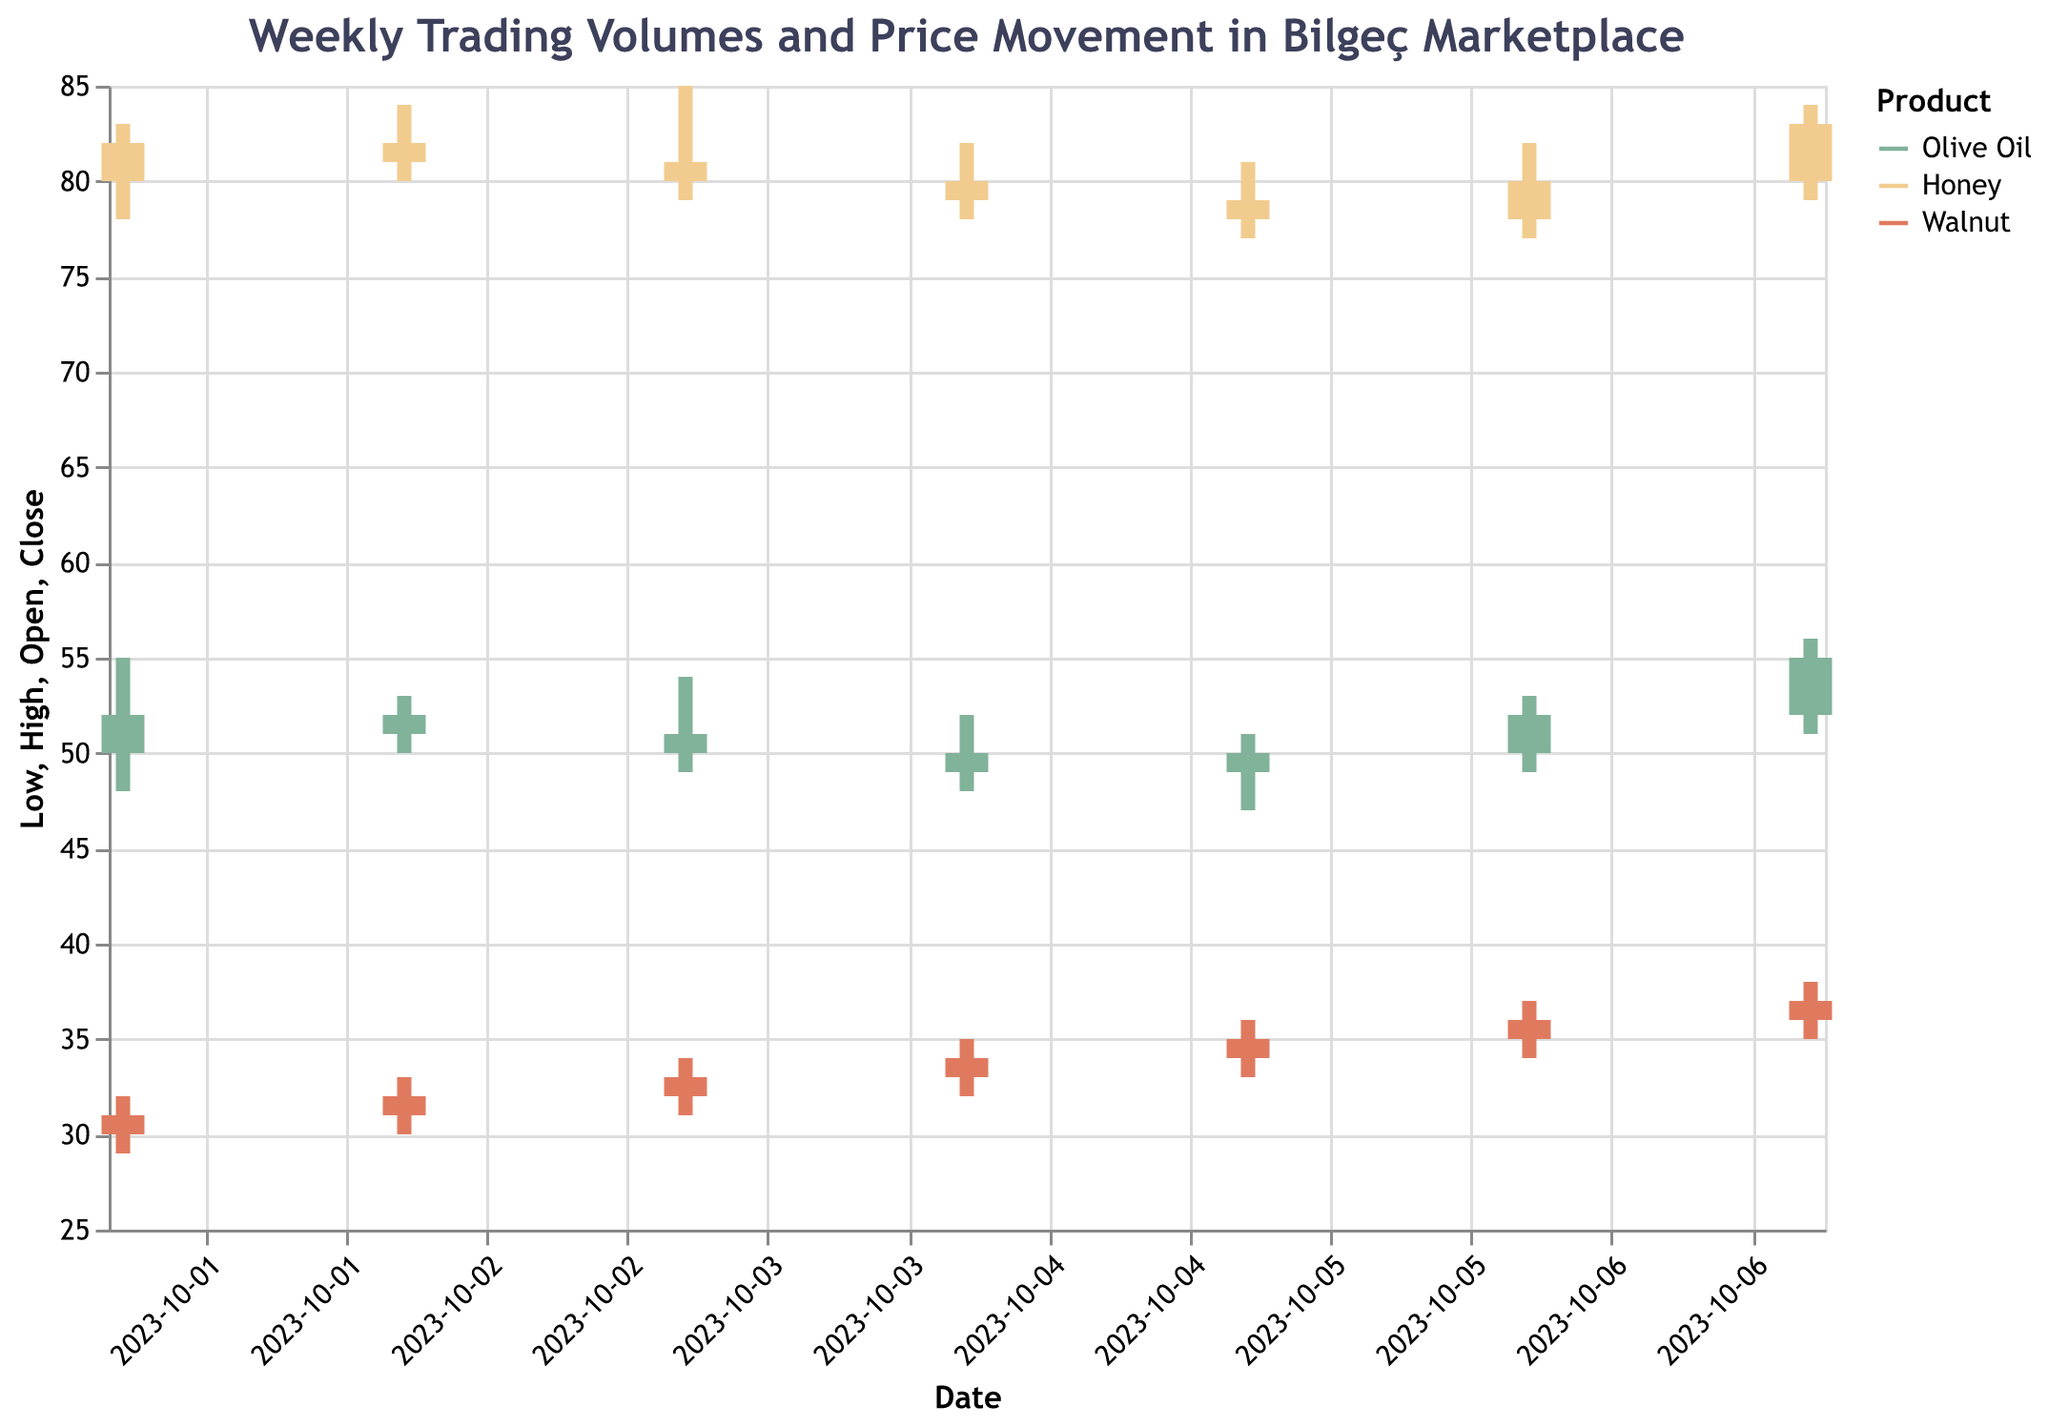What are the three products shown in the figure? The figure's legend shows three different colors representing the products Olive Oil, Honey, and Walnut.
Answer: Olive Oil, Honey, Walnut On which date did Olive Oil have the highest closing price, and what was that price? Observing the chart, the highest closing price for Olive Oil (shown in the relevant color) is on 2023-10-07, with a closing price of 55.
Answer: 2023-10-07, 55 What is the average closing price of Honey over the week? The closing prices of Honey are 82, 81, 80, 79, 78, 80, and 83. Adding them up gives 563, and the average is 563 / 7.
Answer: 81 Which product had the highest trading volume on October 1st? By comparing the vertical bars indicating volume on 2023-10-01, Honey had the highest volume represented by the largest bar.
Answer: Honey How much did the price of Walnut increase from the opening price on 2023-10-01 to the closing price on 2023-10-07? The opening price on 2023-10-01 was 30, and the closing price on 2023-10-07 was 37. The increase is 37 - 30.
Answer: 7 Which product showed the least price volatility over the week? Price volatility can be observed by the range between the high and low prices; Walnut showed the smallest price range throughout the week.
Answer: Walnut On which date did Olive Oil have its lowest trading volume, and what was that volume? Checking the volume bars for Olive Oil for the week, the lowest volume was on 2023-10-04, at 120.
Answer: 2023-10-04, 120 Compare the highest prices reached by each product over the week? The highest prices for Olive Oil, Honey, and Walnut were 56, 85, and 38, respectively. Therefore, Honey had the highest peak.
Answer: Honey: 85, Olive Oil: 56, Walnut: 38 